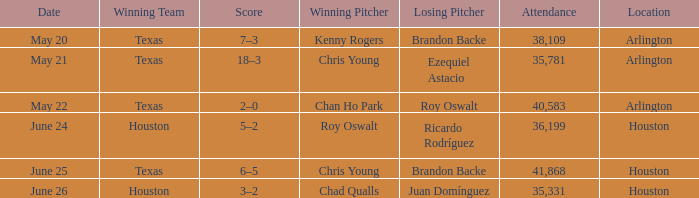What place has a date set for may 21? Arlington. 